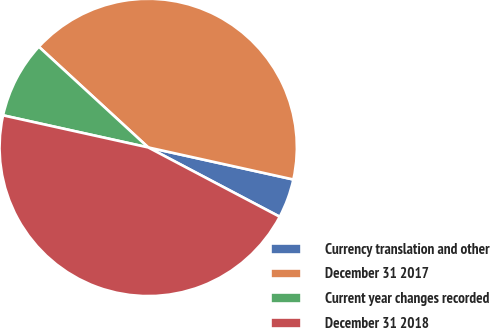Convert chart. <chart><loc_0><loc_0><loc_500><loc_500><pie_chart><fcel>Currency translation and other<fcel>December 31 2017<fcel>Current year changes recorded<fcel>December 31 2018<nl><fcel>4.26%<fcel>41.62%<fcel>8.38%<fcel>45.74%<nl></chart> 